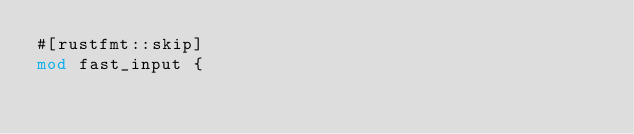Convert code to text. <code><loc_0><loc_0><loc_500><loc_500><_Rust_>#[rustfmt::skip]
mod fast_input {</code> 